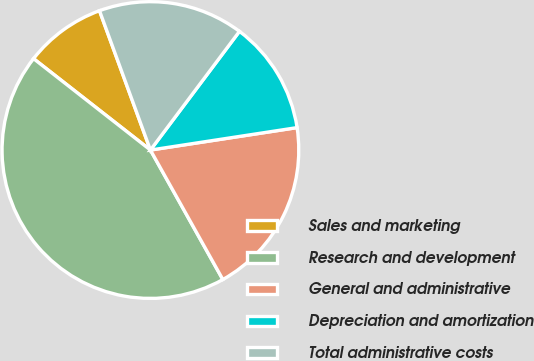Convert chart to OTSL. <chart><loc_0><loc_0><loc_500><loc_500><pie_chart><fcel>Sales and marketing<fcel>Research and development<fcel>General and administrative<fcel>Depreciation and amortization<fcel>Total administrative costs<nl><fcel>8.86%<fcel>43.68%<fcel>19.3%<fcel>12.34%<fcel>15.82%<nl></chart> 